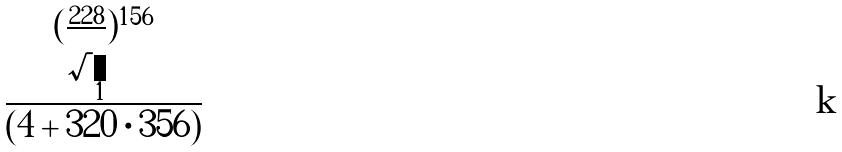<formula> <loc_0><loc_0><loc_500><loc_500>\frac { ( \frac { 2 2 8 } { \sqrt { 1 } } ) ^ { 1 5 6 } } { ( 4 + 3 2 0 \cdot 3 5 6 ) }</formula> 